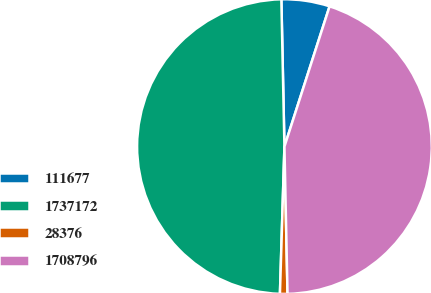Convert chart. <chart><loc_0><loc_0><loc_500><loc_500><pie_chart><fcel>111677<fcel>1737172<fcel>28376<fcel>1708796<nl><fcel>5.29%<fcel>49.18%<fcel>0.82%<fcel>44.71%<nl></chart> 